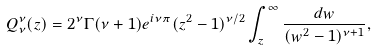<formula> <loc_0><loc_0><loc_500><loc_500>Q _ { \nu } ^ { \nu } ( z ) = 2 ^ { \nu } \Gamma ( \nu + 1 ) e ^ { i \nu \pi } ( z ^ { 2 } - 1 ) ^ { \nu / 2 } \int _ { z } ^ { \infty } \frac { d w } { ( w ^ { 2 } - 1 ) ^ { \nu + 1 } } ,</formula> 